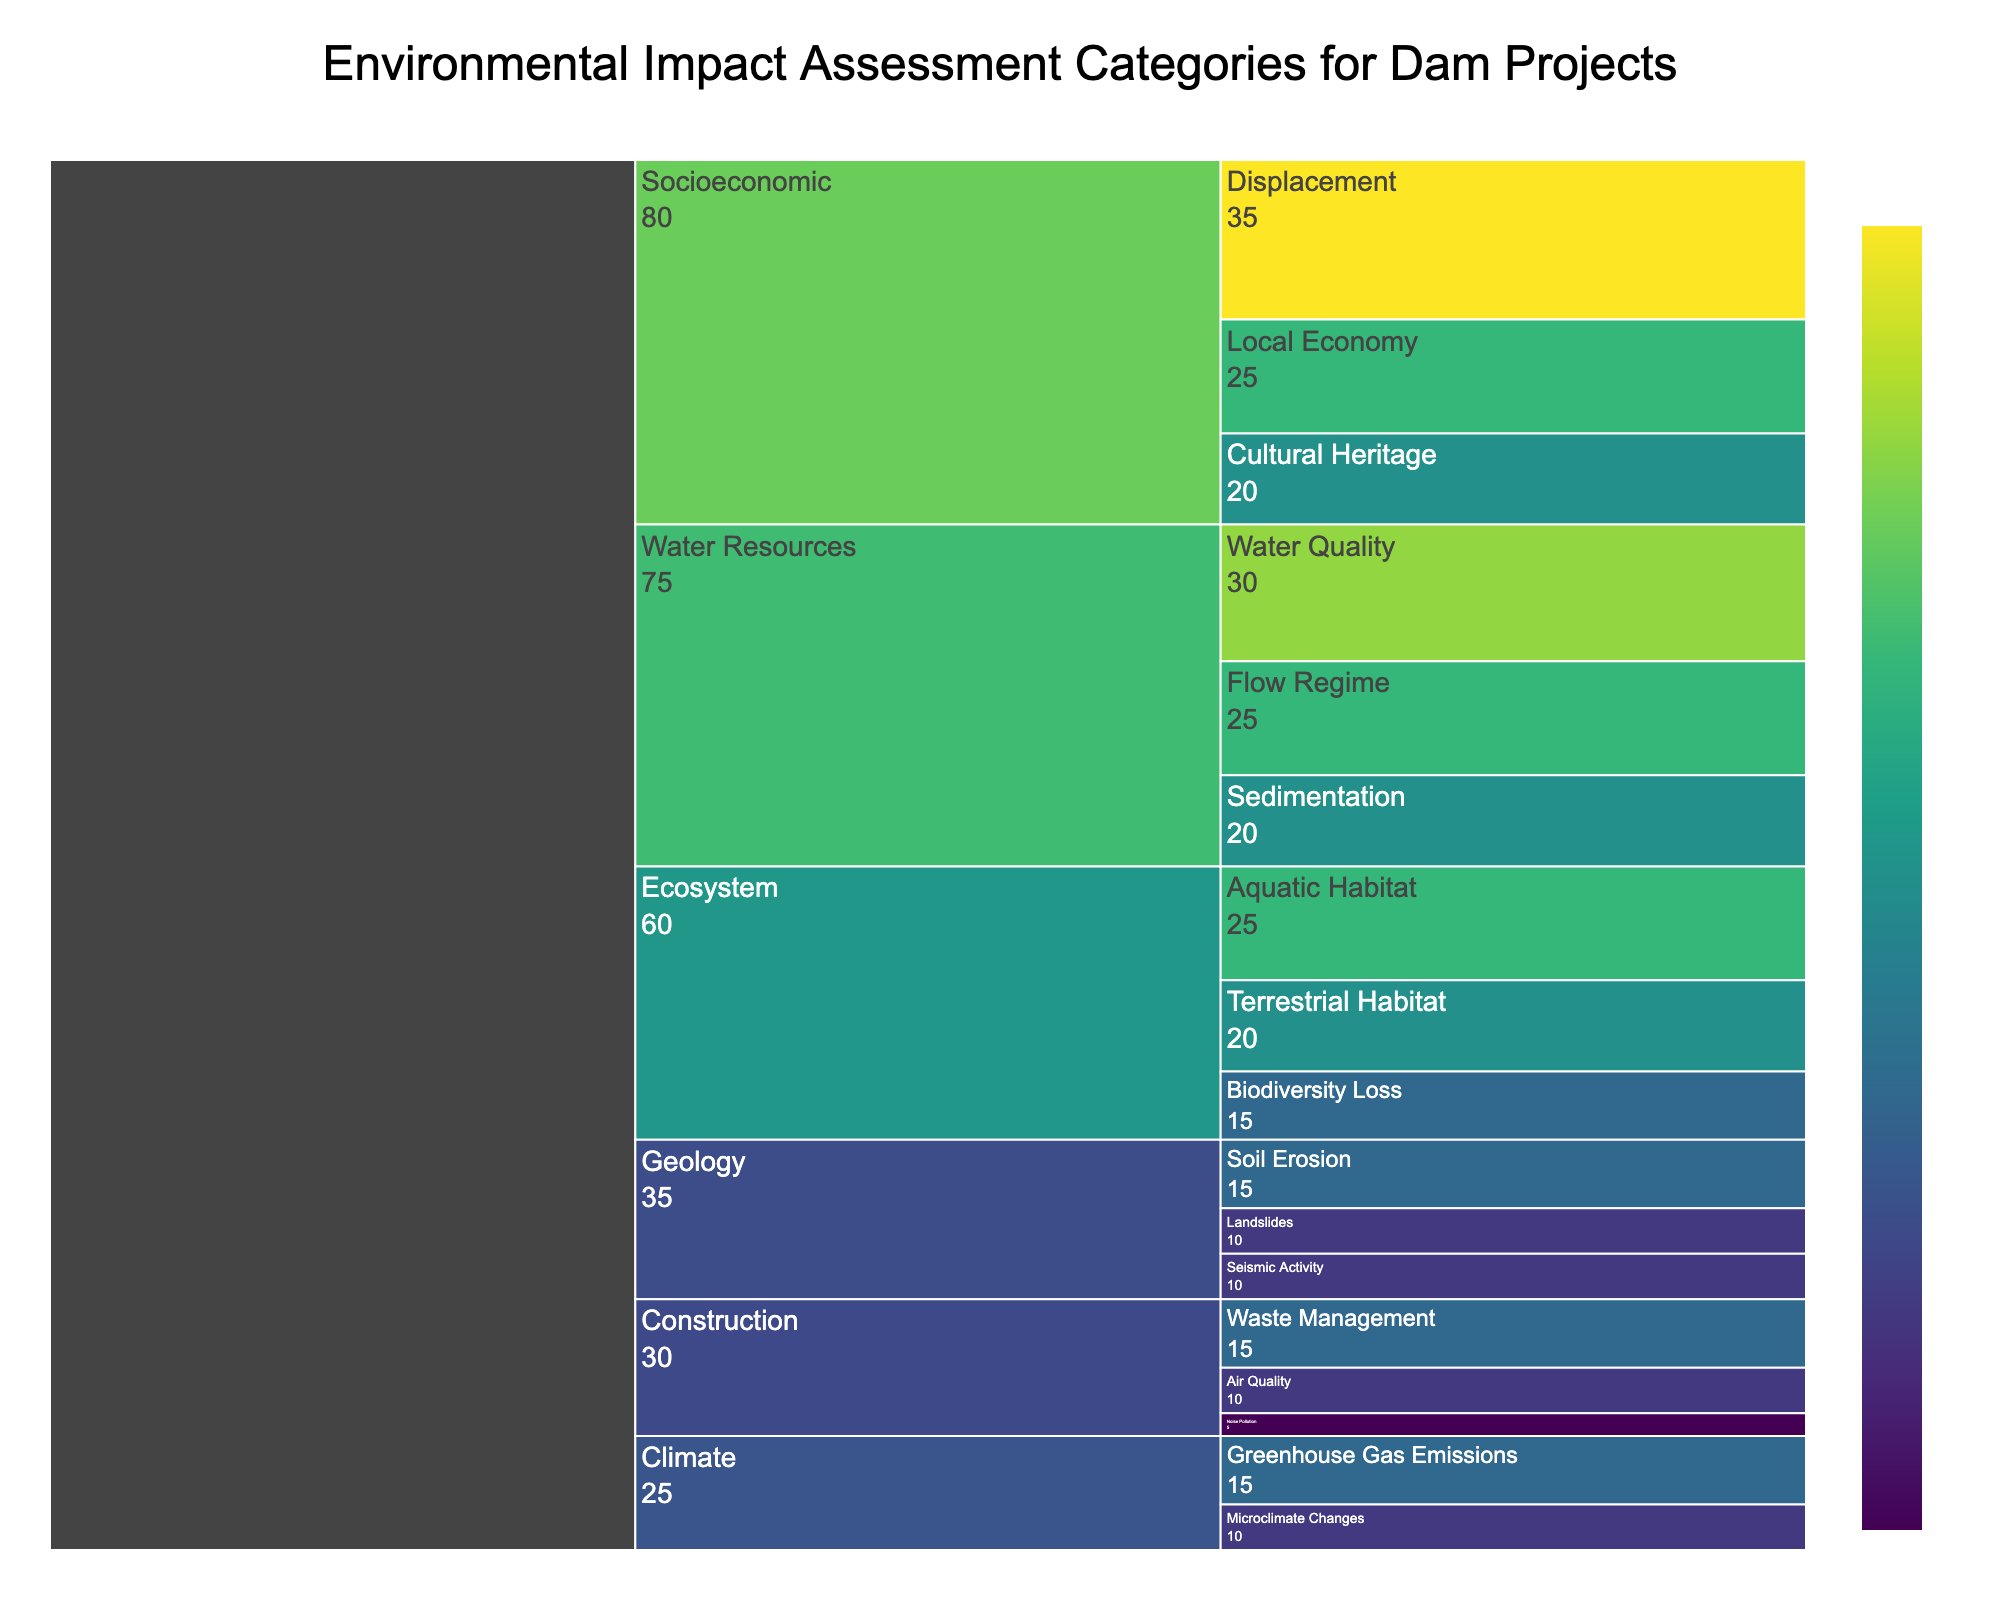What is the title of the Icicle Chart? The title is displayed prominently at the top of the chart, providing an immediate understanding of what the chart is about. It indicates the overall theme or the dataset being visualized.
Answer: Environmental Impact Assessment Categories for Dam Projects Which category has the highest impact value? To find this, sum up the impact values for all subcategories within each category. The category with the highest total is the one we are looking for. Summing up the impacts: Ecosystem (60), Water Resources (75), Climate (25), Socioeconomic (80), Geology (35), Construction (30). Hence, Socioeconomic has the highest impact.
Answer: Socioeconomic How many subcategories are shown in the 'Ecosystem' category? Count the subcategories listed under 'Ecosystem' in the chart. We can see from the dataset that there are three subcategories listed under this category.
Answer: 3 Which subcategory under 'Water Resources' has the lowest impact? Look within the 'Water Resources' category and compare the impact values of each subcategory. Sedimentation has an impact of 20, which is lower than Water Quality (30) and Flow Regime (25).
Answer: Sedimentation What is the combined impact of all 'Geology' subcategories? Add up the values of all subcategories under the 'Geology' category: Seismic Activity (10), Soil Erosion (15), and Landslides (10). Summing these values gives us 10 + 15 + 10 = 35.
Answer: 35 Compare the impact of 'Local Economy' under 'Socioeconomic' to 'Greenhouse Gas Emissions' under 'Climate'. Which one is higher? Identify the impact values of 'Local Economy' (25) and 'Greenhouse Gas Emissions' (15) and compare them directly. 25 is greater than 15.
Answer: Local Economy What percentage of the total impact does the 'Displacement' subcategory contribute to? First, calculate the total sum of all impact values from all subcategories which equals 300. The impact value for 'Displacement' is 35. The percentage can be found by (35/300)*100.
Answer: 11.67% In the 'Construction' category, which subcategory has the highest impact? Within 'Construction', compare the impact values for Noise Pollution (5), Air Quality (10), and Waste Management (15). Waste Management has the highest impact.
Answer: Waste Management If you combine the impact of 'Biodiversity Loss' and 'Flow Regime', what is the result? Add the impact value of 'Biodiversity Loss' under 'Ecosystem' (15) and 'Flow Regime' under 'Water Resources' (25). The combined impact is 15 + 25.
Answer: 40 Which categories have subcategories with an impact value of 10? Identify subcategories with an impact value of 10 and note their respective categories: Microclimate Changes under 'Climate', Seismic Activity and Landslides under 'Geology', and Air Quality under 'Construction'.
Answer: Climate, Geology, Construction 